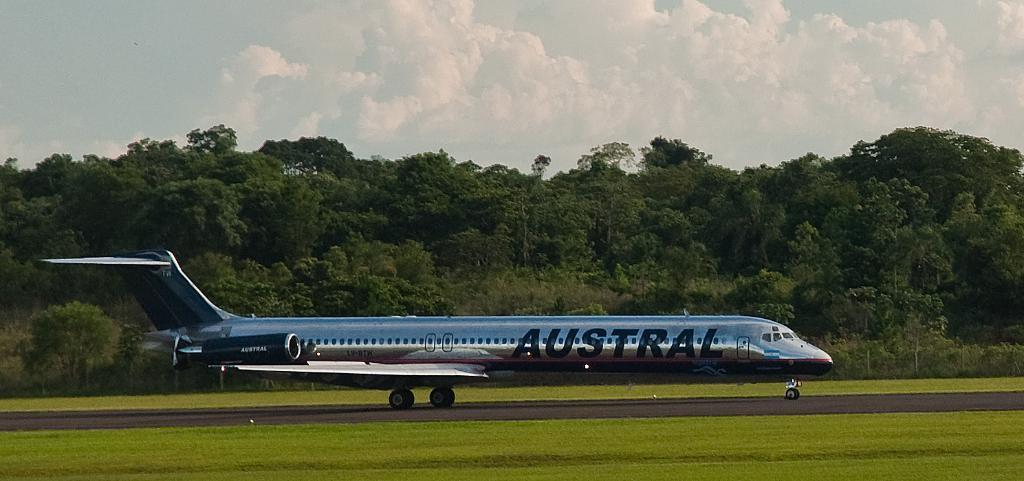<image>
Provide a brief description of the given image. A silver airplane with AUSTRAL on the side sits on a runway in front of some trees. 